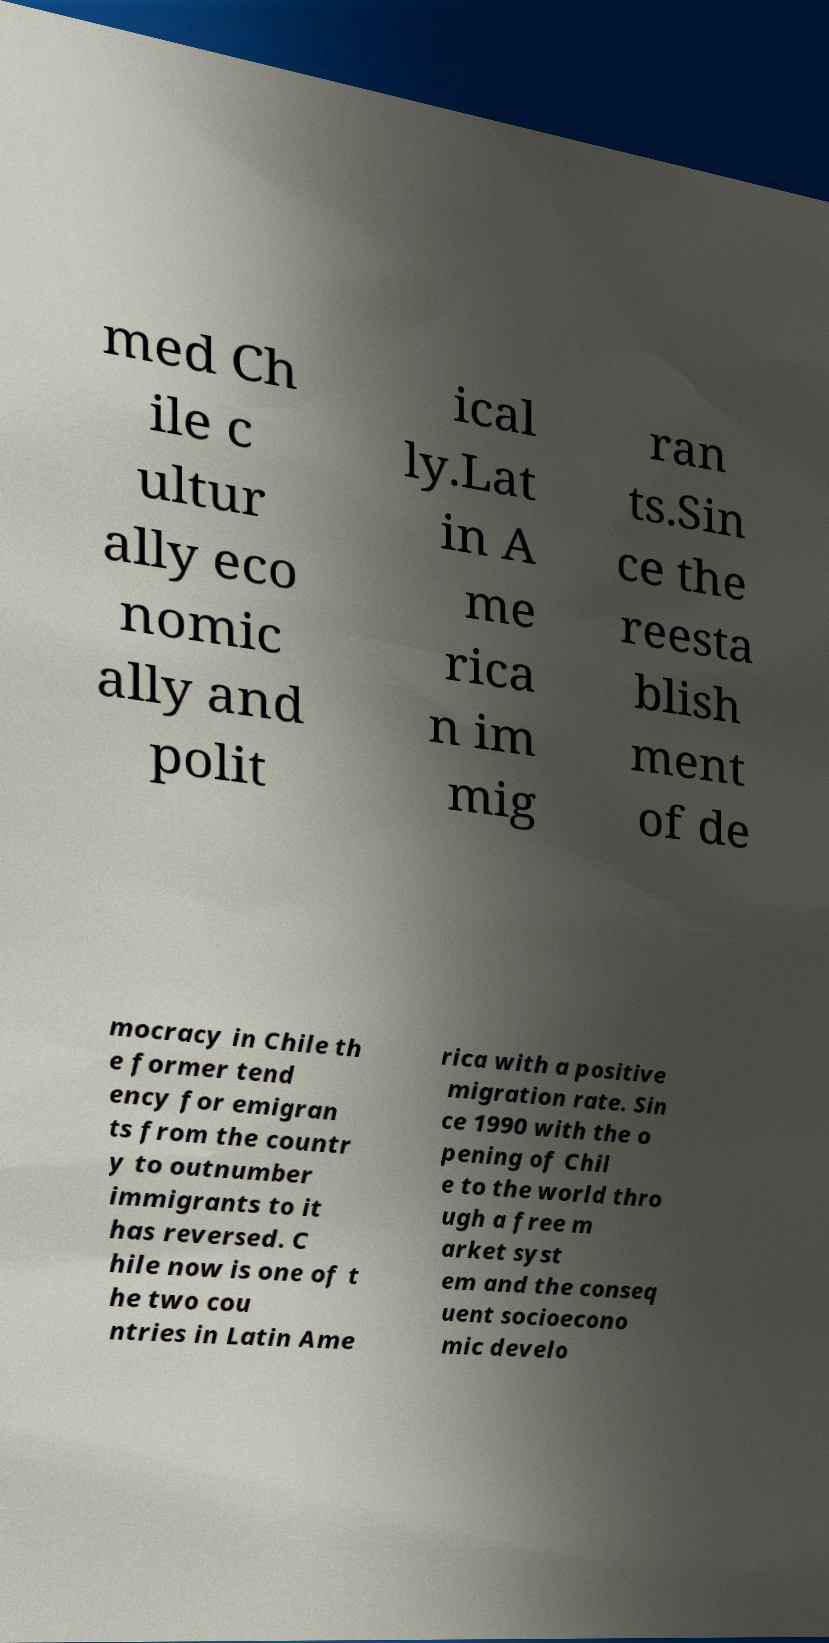What messages or text are displayed in this image? I need them in a readable, typed format. med Ch ile c ultur ally eco nomic ally and polit ical ly.Lat in A me rica n im mig ran ts.Sin ce the reesta blish ment of de mocracy in Chile th e former tend ency for emigran ts from the countr y to outnumber immigrants to it has reversed. C hile now is one of t he two cou ntries in Latin Ame rica with a positive migration rate. Sin ce 1990 with the o pening of Chil e to the world thro ugh a free m arket syst em and the conseq uent socioecono mic develo 